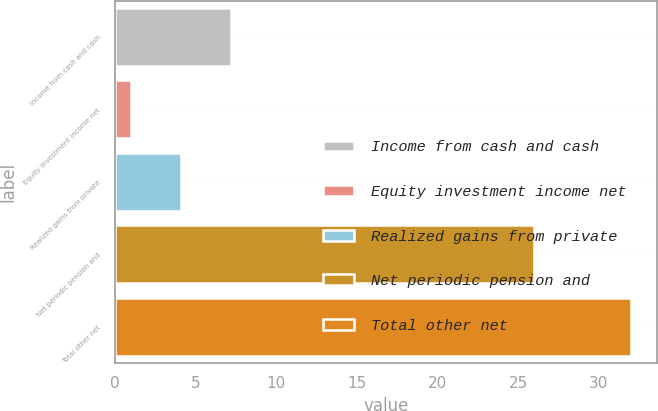Convert chart. <chart><loc_0><loc_0><loc_500><loc_500><bar_chart><fcel>Income from cash and cash<fcel>Equity investment income net<fcel>Realized gains from private<fcel>Net periodic pension and<fcel>Total other net<nl><fcel>7.2<fcel>1<fcel>4.1<fcel>26<fcel>32<nl></chart> 